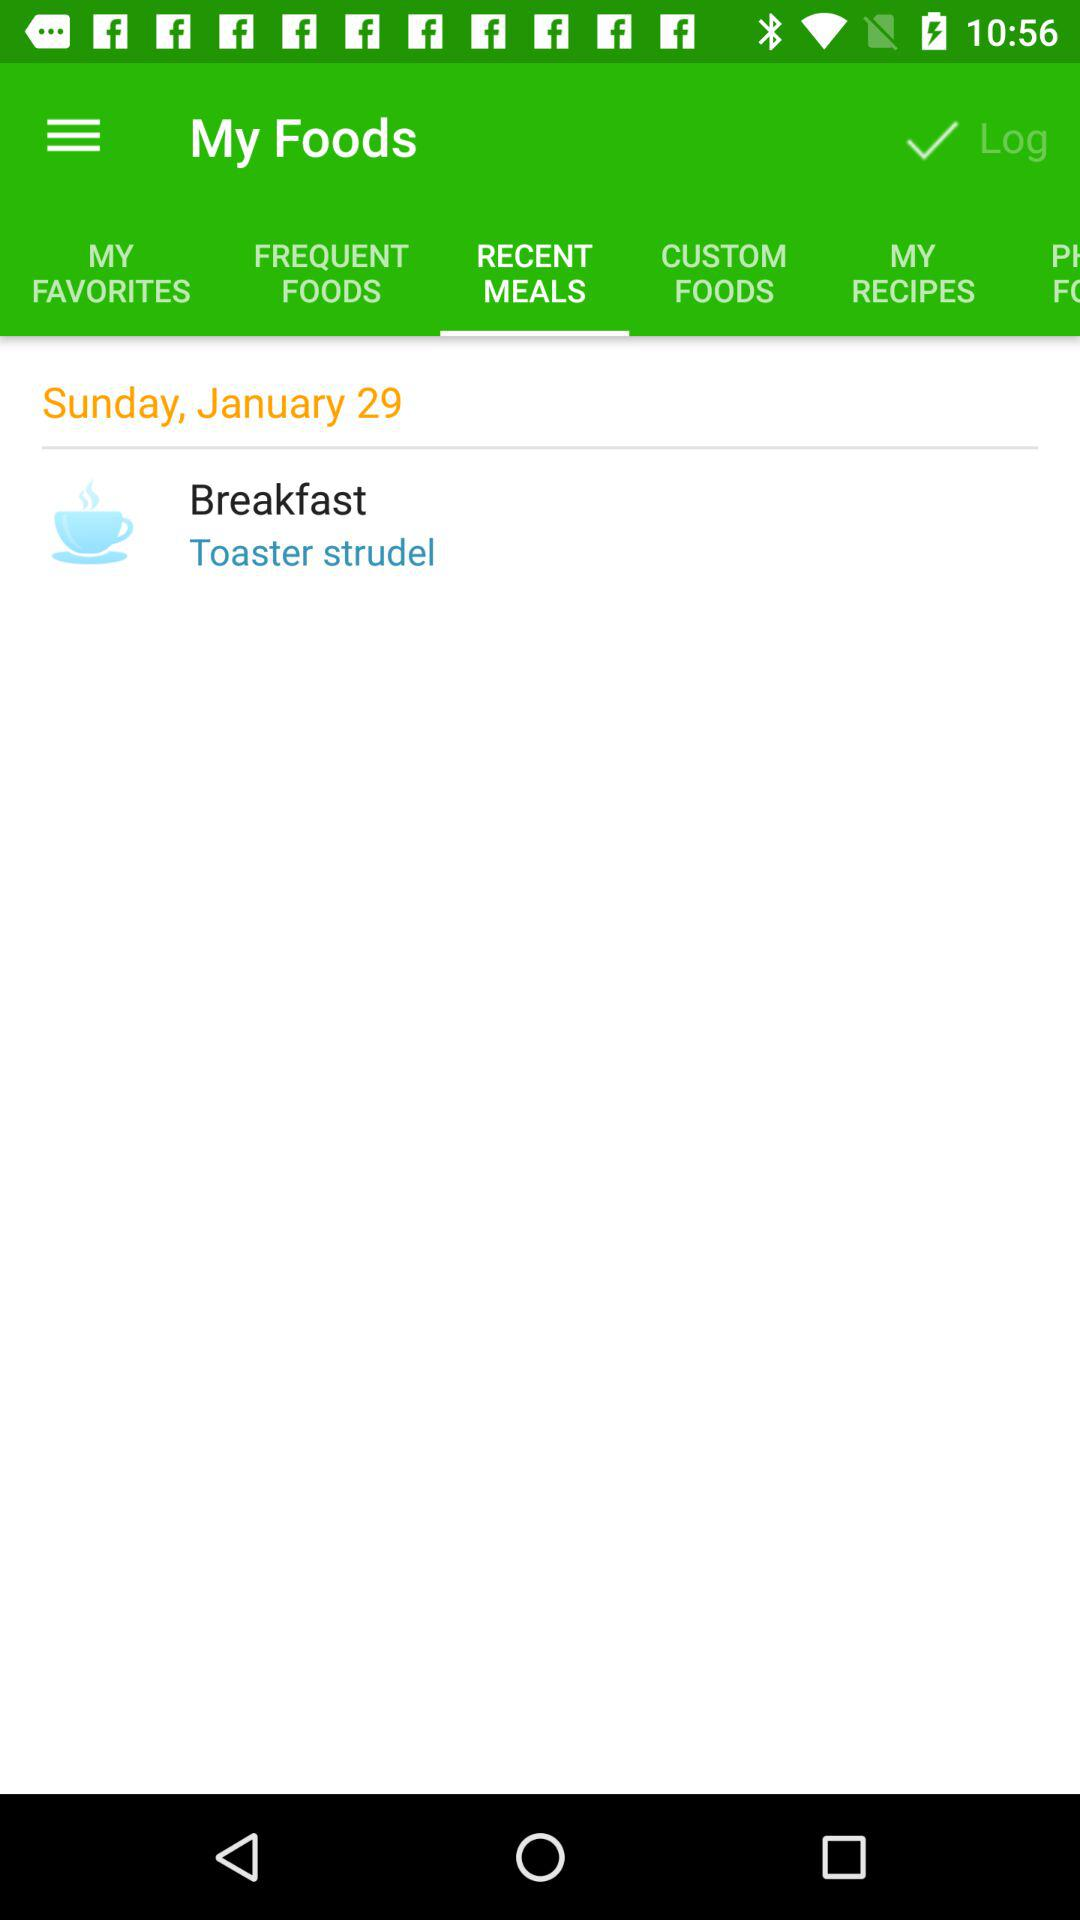What is the date? The date is Sunday, January 29. 